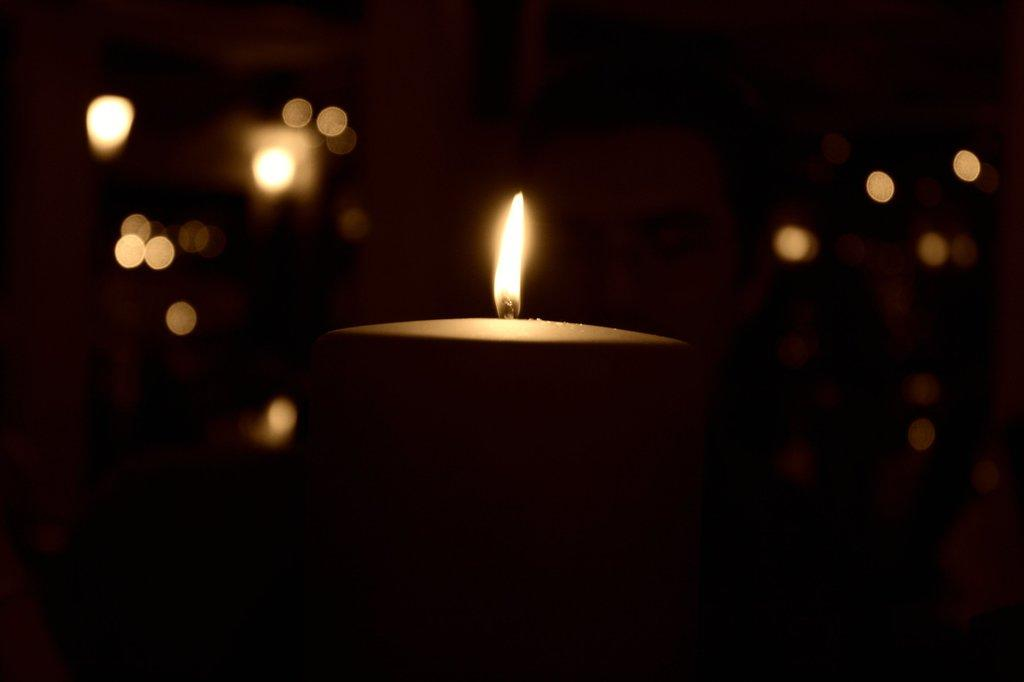What object can be seen in the image? There is a candle in the image. How would you describe the lighting in the image? The image is dark. What type of square object is present in the image? There is no square object present in the image; it only features a candle. 